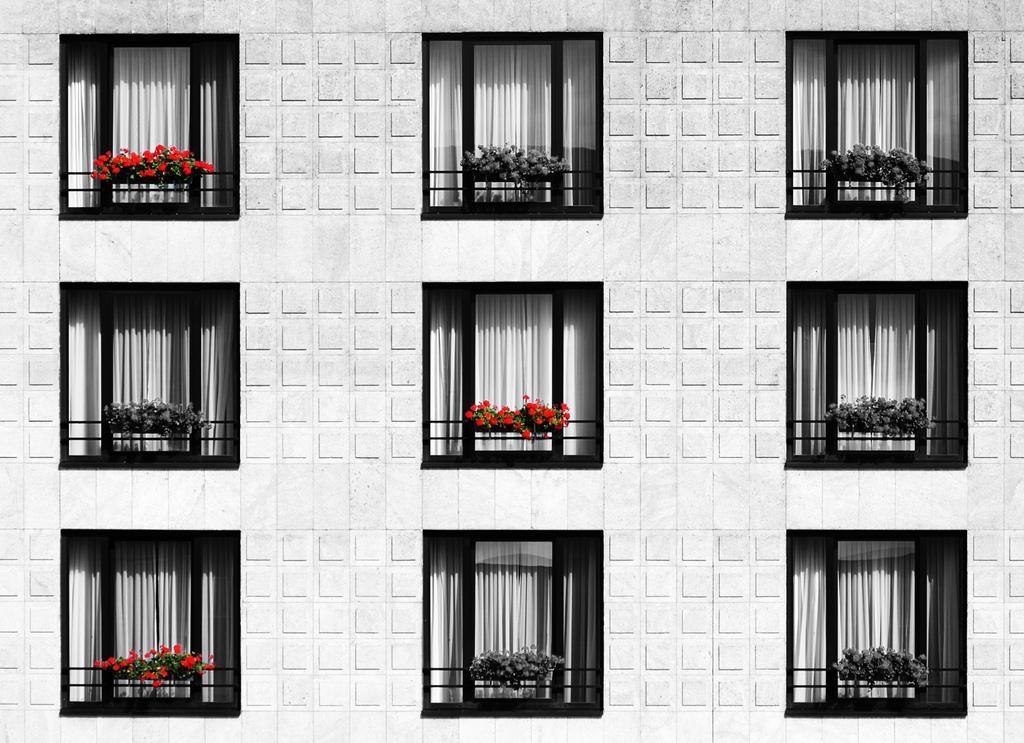Can you describe this image briefly? In this picture there is building elevation on which we can see windows, curtains and flowers pots in the balcony. 